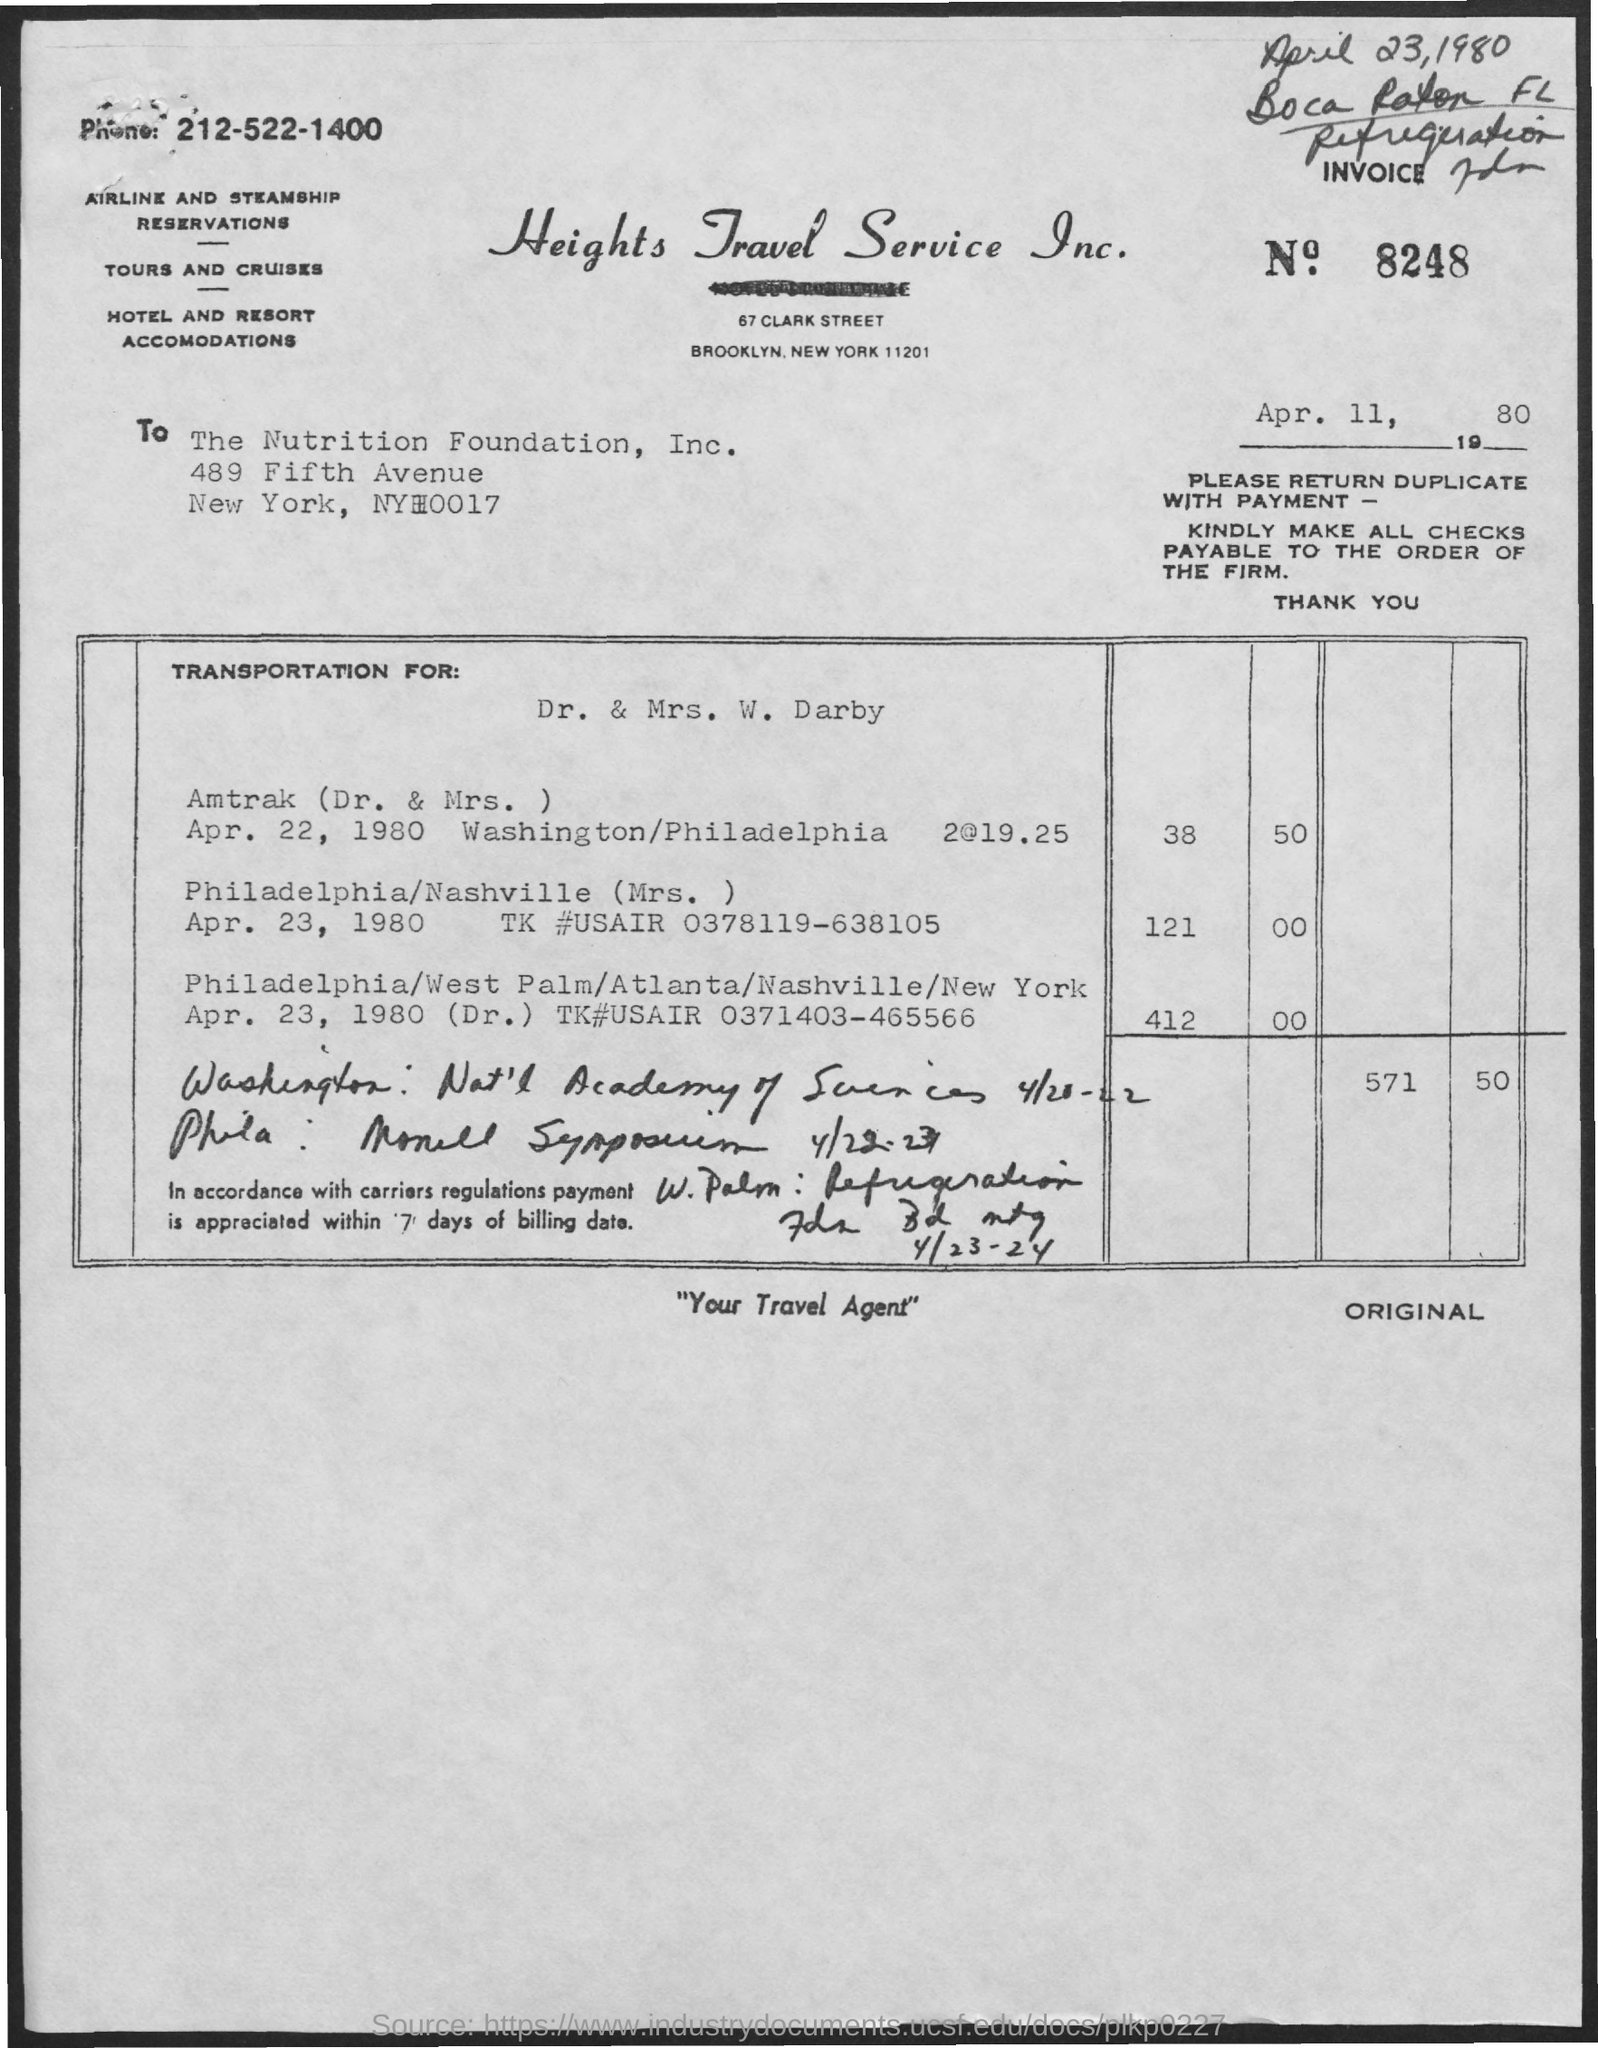Mention a couple of crucial points in this snapshot. The name of the travel service is Heights Travel Service Inc. What is the date mentioned? It is April 11, 1980. The invoice number is 8248. 